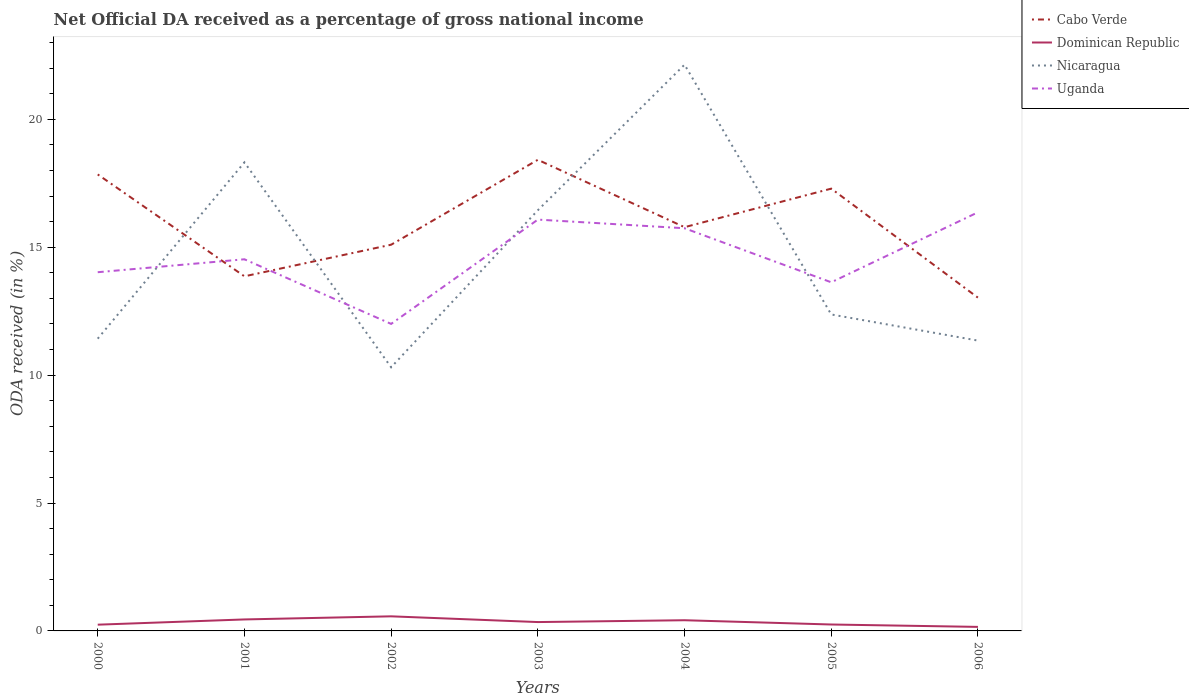How many different coloured lines are there?
Offer a very short reply. 4. Is the number of lines equal to the number of legend labels?
Offer a terse response. Yes. Across all years, what is the maximum net official DA received in Uganda?
Provide a succinct answer. 12. What is the total net official DA received in Nicaragua in the graph?
Provide a succinct answer. 1.02. What is the difference between the highest and the second highest net official DA received in Dominican Republic?
Make the answer very short. 0.41. What is the difference between the highest and the lowest net official DA received in Dominican Republic?
Keep it short and to the point. 3. How many lines are there?
Offer a very short reply. 4. Are the values on the major ticks of Y-axis written in scientific E-notation?
Provide a short and direct response. No. Does the graph contain any zero values?
Your response must be concise. No. Does the graph contain grids?
Your answer should be compact. No. What is the title of the graph?
Provide a short and direct response. Net Official DA received as a percentage of gross national income. What is the label or title of the Y-axis?
Your response must be concise. ODA received (in %). What is the ODA received (in %) of Cabo Verde in 2000?
Ensure brevity in your answer.  17.84. What is the ODA received (in %) in Dominican Republic in 2000?
Offer a very short reply. 0.24. What is the ODA received (in %) of Nicaragua in 2000?
Provide a succinct answer. 11.42. What is the ODA received (in %) of Uganda in 2000?
Keep it short and to the point. 14.02. What is the ODA received (in %) of Cabo Verde in 2001?
Provide a short and direct response. 13.86. What is the ODA received (in %) of Dominican Republic in 2001?
Keep it short and to the point. 0.45. What is the ODA received (in %) of Nicaragua in 2001?
Offer a terse response. 18.32. What is the ODA received (in %) in Uganda in 2001?
Your response must be concise. 14.53. What is the ODA received (in %) of Cabo Verde in 2002?
Your response must be concise. 15.1. What is the ODA received (in %) in Dominican Republic in 2002?
Provide a succinct answer. 0.57. What is the ODA received (in %) in Nicaragua in 2002?
Make the answer very short. 10.31. What is the ODA received (in %) of Uganda in 2002?
Your answer should be compact. 12. What is the ODA received (in %) in Cabo Verde in 2003?
Provide a short and direct response. 18.42. What is the ODA received (in %) in Dominican Republic in 2003?
Give a very brief answer. 0.35. What is the ODA received (in %) of Nicaragua in 2003?
Provide a succinct answer. 16.44. What is the ODA received (in %) of Uganda in 2003?
Your response must be concise. 16.08. What is the ODA received (in %) in Cabo Verde in 2004?
Your answer should be very brief. 15.78. What is the ODA received (in %) in Dominican Republic in 2004?
Your answer should be very brief. 0.42. What is the ODA received (in %) of Nicaragua in 2004?
Give a very brief answer. 22.13. What is the ODA received (in %) of Uganda in 2004?
Offer a terse response. 15.74. What is the ODA received (in %) of Cabo Verde in 2005?
Make the answer very short. 17.29. What is the ODA received (in %) of Dominican Republic in 2005?
Provide a short and direct response. 0.25. What is the ODA received (in %) of Nicaragua in 2005?
Your answer should be very brief. 12.37. What is the ODA received (in %) of Uganda in 2005?
Provide a short and direct response. 13.63. What is the ODA received (in %) in Cabo Verde in 2006?
Offer a very short reply. 13.03. What is the ODA received (in %) of Dominican Republic in 2006?
Ensure brevity in your answer.  0.16. What is the ODA received (in %) of Nicaragua in 2006?
Ensure brevity in your answer.  11.35. What is the ODA received (in %) of Uganda in 2006?
Keep it short and to the point. 16.36. Across all years, what is the maximum ODA received (in %) in Cabo Verde?
Offer a very short reply. 18.42. Across all years, what is the maximum ODA received (in %) of Dominican Republic?
Keep it short and to the point. 0.57. Across all years, what is the maximum ODA received (in %) in Nicaragua?
Your response must be concise. 22.13. Across all years, what is the maximum ODA received (in %) of Uganda?
Offer a terse response. 16.36. Across all years, what is the minimum ODA received (in %) of Cabo Verde?
Give a very brief answer. 13.03. Across all years, what is the minimum ODA received (in %) of Dominican Republic?
Your answer should be very brief. 0.16. Across all years, what is the minimum ODA received (in %) in Nicaragua?
Offer a terse response. 10.31. Across all years, what is the minimum ODA received (in %) in Uganda?
Offer a very short reply. 12. What is the total ODA received (in %) of Cabo Verde in the graph?
Offer a very short reply. 111.31. What is the total ODA received (in %) of Dominican Republic in the graph?
Provide a succinct answer. 2.44. What is the total ODA received (in %) in Nicaragua in the graph?
Provide a short and direct response. 102.34. What is the total ODA received (in %) in Uganda in the graph?
Provide a succinct answer. 102.36. What is the difference between the ODA received (in %) of Cabo Verde in 2000 and that in 2001?
Offer a very short reply. 3.98. What is the difference between the ODA received (in %) of Dominican Republic in 2000 and that in 2001?
Offer a very short reply. -0.2. What is the difference between the ODA received (in %) in Nicaragua in 2000 and that in 2001?
Keep it short and to the point. -6.89. What is the difference between the ODA received (in %) in Uganda in 2000 and that in 2001?
Your response must be concise. -0.51. What is the difference between the ODA received (in %) in Cabo Verde in 2000 and that in 2002?
Offer a terse response. 2.75. What is the difference between the ODA received (in %) in Dominican Republic in 2000 and that in 2002?
Your response must be concise. -0.33. What is the difference between the ODA received (in %) in Nicaragua in 2000 and that in 2002?
Keep it short and to the point. 1.12. What is the difference between the ODA received (in %) of Uganda in 2000 and that in 2002?
Give a very brief answer. 2.02. What is the difference between the ODA received (in %) in Cabo Verde in 2000 and that in 2003?
Provide a short and direct response. -0.57. What is the difference between the ODA received (in %) in Dominican Republic in 2000 and that in 2003?
Make the answer very short. -0.1. What is the difference between the ODA received (in %) in Nicaragua in 2000 and that in 2003?
Offer a very short reply. -5.02. What is the difference between the ODA received (in %) of Uganda in 2000 and that in 2003?
Offer a terse response. -2.06. What is the difference between the ODA received (in %) in Cabo Verde in 2000 and that in 2004?
Ensure brevity in your answer.  2.06. What is the difference between the ODA received (in %) of Dominican Republic in 2000 and that in 2004?
Keep it short and to the point. -0.17. What is the difference between the ODA received (in %) of Nicaragua in 2000 and that in 2004?
Make the answer very short. -10.71. What is the difference between the ODA received (in %) of Uganda in 2000 and that in 2004?
Your answer should be very brief. -1.72. What is the difference between the ODA received (in %) of Cabo Verde in 2000 and that in 2005?
Your answer should be very brief. 0.56. What is the difference between the ODA received (in %) in Dominican Republic in 2000 and that in 2005?
Give a very brief answer. -0.01. What is the difference between the ODA received (in %) of Nicaragua in 2000 and that in 2005?
Give a very brief answer. -0.95. What is the difference between the ODA received (in %) of Uganda in 2000 and that in 2005?
Provide a short and direct response. 0.39. What is the difference between the ODA received (in %) of Cabo Verde in 2000 and that in 2006?
Provide a succinct answer. 4.82. What is the difference between the ODA received (in %) in Dominican Republic in 2000 and that in 2006?
Ensure brevity in your answer.  0.09. What is the difference between the ODA received (in %) in Nicaragua in 2000 and that in 2006?
Ensure brevity in your answer.  0.07. What is the difference between the ODA received (in %) of Uganda in 2000 and that in 2006?
Give a very brief answer. -2.34. What is the difference between the ODA received (in %) in Cabo Verde in 2001 and that in 2002?
Give a very brief answer. -1.24. What is the difference between the ODA received (in %) of Dominican Republic in 2001 and that in 2002?
Provide a succinct answer. -0.12. What is the difference between the ODA received (in %) in Nicaragua in 2001 and that in 2002?
Ensure brevity in your answer.  8.01. What is the difference between the ODA received (in %) of Uganda in 2001 and that in 2002?
Provide a succinct answer. 2.53. What is the difference between the ODA received (in %) of Cabo Verde in 2001 and that in 2003?
Keep it short and to the point. -4.55. What is the difference between the ODA received (in %) in Dominican Republic in 2001 and that in 2003?
Keep it short and to the point. 0.1. What is the difference between the ODA received (in %) of Nicaragua in 2001 and that in 2003?
Make the answer very short. 1.87. What is the difference between the ODA received (in %) in Uganda in 2001 and that in 2003?
Give a very brief answer. -1.55. What is the difference between the ODA received (in %) of Cabo Verde in 2001 and that in 2004?
Give a very brief answer. -1.92. What is the difference between the ODA received (in %) of Dominican Republic in 2001 and that in 2004?
Keep it short and to the point. 0.03. What is the difference between the ODA received (in %) of Nicaragua in 2001 and that in 2004?
Keep it short and to the point. -3.82. What is the difference between the ODA received (in %) of Uganda in 2001 and that in 2004?
Your answer should be compact. -1.21. What is the difference between the ODA received (in %) in Cabo Verde in 2001 and that in 2005?
Make the answer very short. -3.43. What is the difference between the ODA received (in %) in Dominican Republic in 2001 and that in 2005?
Your answer should be compact. 0.2. What is the difference between the ODA received (in %) in Nicaragua in 2001 and that in 2005?
Offer a very short reply. 5.95. What is the difference between the ODA received (in %) in Uganda in 2001 and that in 2005?
Your response must be concise. 0.9. What is the difference between the ODA received (in %) of Cabo Verde in 2001 and that in 2006?
Keep it short and to the point. 0.83. What is the difference between the ODA received (in %) of Dominican Republic in 2001 and that in 2006?
Give a very brief answer. 0.29. What is the difference between the ODA received (in %) in Nicaragua in 2001 and that in 2006?
Offer a very short reply. 6.97. What is the difference between the ODA received (in %) in Uganda in 2001 and that in 2006?
Your answer should be compact. -1.84. What is the difference between the ODA received (in %) in Cabo Verde in 2002 and that in 2003?
Your answer should be compact. -3.32. What is the difference between the ODA received (in %) in Dominican Republic in 2002 and that in 2003?
Keep it short and to the point. 0.22. What is the difference between the ODA received (in %) of Nicaragua in 2002 and that in 2003?
Give a very brief answer. -6.14. What is the difference between the ODA received (in %) in Uganda in 2002 and that in 2003?
Make the answer very short. -4.08. What is the difference between the ODA received (in %) of Cabo Verde in 2002 and that in 2004?
Give a very brief answer. -0.69. What is the difference between the ODA received (in %) of Dominican Republic in 2002 and that in 2004?
Provide a succinct answer. 0.15. What is the difference between the ODA received (in %) in Nicaragua in 2002 and that in 2004?
Give a very brief answer. -11.83. What is the difference between the ODA received (in %) of Uganda in 2002 and that in 2004?
Your answer should be very brief. -3.74. What is the difference between the ODA received (in %) of Cabo Verde in 2002 and that in 2005?
Your response must be concise. -2.19. What is the difference between the ODA received (in %) in Dominican Republic in 2002 and that in 2005?
Your response must be concise. 0.32. What is the difference between the ODA received (in %) of Nicaragua in 2002 and that in 2005?
Offer a terse response. -2.06. What is the difference between the ODA received (in %) in Uganda in 2002 and that in 2005?
Keep it short and to the point. -1.63. What is the difference between the ODA received (in %) of Cabo Verde in 2002 and that in 2006?
Your answer should be compact. 2.07. What is the difference between the ODA received (in %) in Dominican Republic in 2002 and that in 2006?
Your response must be concise. 0.41. What is the difference between the ODA received (in %) of Nicaragua in 2002 and that in 2006?
Make the answer very short. -1.04. What is the difference between the ODA received (in %) in Uganda in 2002 and that in 2006?
Provide a short and direct response. -4.36. What is the difference between the ODA received (in %) of Cabo Verde in 2003 and that in 2004?
Your response must be concise. 2.63. What is the difference between the ODA received (in %) in Dominican Republic in 2003 and that in 2004?
Make the answer very short. -0.07. What is the difference between the ODA received (in %) in Nicaragua in 2003 and that in 2004?
Your answer should be compact. -5.69. What is the difference between the ODA received (in %) in Uganda in 2003 and that in 2004?
Offer a very short reply. 0.34. What is the difference between the ODA received (in %) of Cabo Verde in 2003 and that in 2005?
Your answer should be compact. 1.13. What is the difference between the ODA received (in %) in Dominican Republic in 2003 and that in 2005?
Your response must be concise. 0.1. What is the difference between the ODA received (in %) in Nicaragua in 2003 and that in 2005?
Your answer should be very brief. 4.07. What is the difference between the ODA received (in %) of Uganda in 2003 and that in 2005?
Your response must be concise. 2.45. What is the difference between the ODA received (in %) in Cabo Verde in 2003 and that in 2006?
Make the answer very short. 5.39. What is the difference between the ODA received (in %) in Dominican Republic in 2003 and that in 2006?
Provide a short and direct response. 0.19. What is the difference between the ODA received (in %) of Nicaragua in 2003 and that in 2006?
Your response must be concise. 5.09. What is the difference between the ODA received (in %) of Uganda in 2003 and that in 2006?
Your response must be concise. -0.29. What is the difference between the ODA received (in %) in Cabo Verde in 2004 and that in 2005?
Keep it short and to the point. -1.51. What is the difference between the ODA received (in %) of Dominican Republic in 2004 and that in 2005?
Offer a terse response. 0.17. What is the difference between the ODA received (in %) in Nicaragua in 2004 and that in 2005?
Ensure brevity in your answer.  9.76. What is the difference between the ODA received (in %) of Uganda in 2004 and that in 2005?
Provide a succinct answer. 2.11. What is the difference between the ODA received (in %) of Cabo Verde in 2004 and that in 2006?
Keep it short and to the point. 2.76. What is the difference between the ODA received (in %) in Dominican Republic in 2004 and that in 2006?
Provide a short and direct response. 0.26. What is the difference between the ODA received (in %) in Nicaragua in 2004 and that in 2006?
Make the answer very short. 10.78. What is the difference between the ODA received (in %) of Uganda in 2004 and that in 2006?
Provide a succinct answer. -0.62. What is the difference between the ODA received (in %) of Cabo Verde in 2005 and that in 2006?
Provide a short and direct response. 4.26. What is the difference between the ODA received (in %) in Dominican Republic in 2005 and that in 2006?
Give a very brief answer. 0.09. What is the difference between the ODA received (in %) of Nicaragua in 2005 and that in 2006?
Make the answer very short. 1.02. What is the difference between the ODA received (in %) in Uganda in 2005 and that in 2006?
Make the answer very short. -2.74. What is the difference between the ODA received (in %) in Cabo Verde in 2000 and the ODA received (in %) in Dominican Republic in 2001?
Offer a terse response. 17.39. What is the difference between the ODA received (in %) in Cabo Verde in 2000 and the ODA received (in %) in Nicaragua in 2001?
Your answer should be very brief. -0.47. What is the difference between the ODA received (in %) of Cabo Verde in 2000 and the ODA received (in %) of Uganda in 2001?
Your response must be concise. 3.32. What is the difference between the ODA received (in %) in Dominican Republic in 2000 and the ODA received (in %) in Nicaragua in 2001?
Your answer should be compact. -18.07. What is the difference between the ODA received (in %) in Dominican Republic in 2000 and the ODA received (in %) in Uganda in 2001?
Give a very brief answer. -14.28. What is the difference between the ODA received (in %) of Nicaragua in 2000 and the ODA received (in %) of Uganda in 2001?
Provide a succinct answer. -3.1. What is the difference between the ODA received (in %) in Cabo Verde in 2000 and the ODA received (in %) in Dominican Republic in 2002?
Provide a short and direct response. 17.27. What is the difference between the ODA received (in %) of Cabo Verde in 2000 and the ODA received (in %) of Nicaragua in 2002?
Provide a short and direct response. 7.54. What is the difference between the ODA received (in %) of Cabo Verde in 2000 and the ODA received (in %) of Uganda in 2002?
Ensure brevity in your answer.  5.84. What is the difference between the ODA received (in %) in Dominican Republic in 2000 and the ODA received (in %) in Nicaragua in 2002?
Your answer should be very brief. -10.06. What is the difference between the ODA received (in %) of Dominican Republic in 2000 and the ODA received (in %) of Uganda in 2002?
Offer a very short reply. -11.76. What is the difference between the ODA received (in %) of Nicaragua in 2000 and the ODA received (in %) of Uganda in 2002?
Your response must be concise. -0.58. What is the difference between the ODA received (in %) in Cabo Verde in 2000 and the ODA received (in %) in Dominican Republic in 2003?
Offer a very short reply. 17.5. What is the difference between the ODA received (in %) of Cabo Verde in 2000 and the ODA received (in %) of Nicaragua in 2003?
Your response must be concise. 1.4. What is the difference between the ODA received (in %) of Cabo Verde in 2000 and the ODA received (in %) of Uganda in 2003?
Offer a very short reply. 1.77. What is the difference between the ODA received (in %) of Dominican Republic in 2000 and the ODA received (in %) of Nicaragua in 2003?
Give a very brief answer. -16.2. What is the difference between the ODA received (in %) of Dominican Republic in 2000 and the ODA received (in %) of Uganda in 2003?
Offer a very short reply. -15.83. What is the difference between the ODA received (in %) in Nicaragua in 2000 and the ODA received (in %) in Uganda in 2003?
Provide a succinct answer. -4.65. What is the difference between the ODA received (in %) of Cabo Verde in 2000 and the ODA received (in %) of Dominican Republic in 2004?
Make the answer very short. 17.43. What is the difference between the ODA received (in %) of Cabo Verde in 2000 and the ODA received (in %) of Nicaragua in 2004?
Provide a short and direct response. -4.29. What is the difference between the ODA received (in %) of Cabo Verde in 2000 and the ODA received (in %) of Uganda in 2004?
Provide a succinct answer. 2.1. What is the difference between the ODA received (in %) of Dominican Republic in 2000 and the ODA received (in %) of Nicaragua in 2004?
Your response must be concise. -21.89. What is the difference between the ODA received (in %) of Dominican Republic in 2000 and the ODA received (in %) of Uganda in 2004?
Offer a terse response. -15.5. What is the difference between the ODA received (in %) of Nicaragua in 2000 and the ODA received (in %) of Uganda in 2004?
Keep it short and to the point. -4.32. What is the difference between the ODA received (in %) in Cabo Verde in 2000 and the ODA received (in %) in Dominican Republic in 2005?
Provide a short and direct response. 17.59. What is the difference between the ODA received (in %) in Cabo Verde in 2000 and the ODA received (in %) in Nicaragua in 2005?
Your answer should be compact. 5.47. What is the difference between the ODA received (in %) in Cabo Verde in 2000 and the ODA received (in %) in Uganda in 2005?
Offer a very short reply. 4.22. What is the difference between the ODA received (in %) in Dominican Republic in 2000 and the ODA received (in %) in Nicaragua in 2005?
Your response must be concise. -12.13. What is the difference between the ODA received (in %) in Dominican Republic in 2000 and the ODA received (in %) in Uganda in 2005?
Give a very brief answer. -13.38. What is the difference between the ODA received (in %) of Nicaragua in 2000 and the ODA received (in %) of Uganda in 2005?
Ensure brevity in your answer.  -2.2. What is the difference between the ODA received (in %) of Cabo Verde in 2000 and the ODA received (in %) of Dominican Republic in 2006?
Give a very brief answer. 17.69. What is the difference between the ODA received (in %) in Cabo Verde in 2000 and the ODA received (in %) in Nicaragua in 2006?
Your answer should be compact. 6.5. What is the difference between the ODA received (in %) in Cabo Verde in 2000 and the ODA received (in %) in Uganda in 2006?
Offer a terse response. 1.48. What is the difference between the ODA received (in %) of Dominican Republic in 2000 and the ODA received (in %) of Nicaragua in 2006?
Your answer should be very brief. -11.1. What is the difference between the ODA received (in %) in Dominican Republic in 2000 and the ODA received (in %) in Uganda in 2006?
Provide a short and direct response. -16.12. What is the difference between the ODA received (in %) in Nicaragua in 2000 and the ODA received (in %) in Uganda in 2006?
Offer a terse response. -4.94. What is the difference between the ODA received (in %) of Cabo Verde in 2001 and the ODA received (in %) of Dominican Republic in 2002?
Your answer should be very brief. 13.29. What is the difference between the ODA received (in %) in Cabo Verde in 2001 and the ODA received (in %) in Nicaragua in 2002?
Offer a terse response. 3.56. What is the difference between the ODA received (in %) of Cabo Verde in 2001 and the ODA received (in %) of Uganda in 2002?
Ensure brevity in your answer.  1.86. What is the difference between the ODA received (in %) of Dominican Republic in 2001 and the ODA received (in %) of Nicaragua in 2002?
Make the answer very short. -9.86. What is the difference between the ODA received (in %) of Dominican Republic in 2001 and the ODA received (in %) of Uganda in 2002?
Give a very brief answer. -11.55. What is the difference between the ODA received (in %) of Nicaragua in 2001 and the ODA received (in %) of Uganda in 2002?
Your response must be concise. 6.32. What is the difference between the ODA received (in %) in Cabo Verde in 2001 and the ODA received (in %) in Dominican Republic in 2003?
Your answer should be compact. 13.51. What is the difference between the ODA received (in %) in Cabo Verde in 2001 and the ODA received (in %) in Nicaragua in 2003?
Keep it short and to the point. -2.58. What is the difference between the ODA received (in %) in Cabo Verde in 2001 and the ODA received (in %) in Uganda in 2003?
Give a very brief answer. -2.22. What is the difference between the ODA received (in %) in Dominican Republic in 2001 and the ODA received (in %) in Nicaragua in 2003?
Ensure brevity in your answer.  -15.99. What is the difference between the ODA received (in %) of Dominican Republic in 2001 and the ODA received (in %) of Uganda in 2003?
Give a very brief answer. -15.63. What is the difference between the ODA received (in %) in Nicaragua in 2001 and the ODA received (in %) in Uganda in 2003?
Offer a very short reply. 2.24. What is the difference between the ODA received (in %) in Cabo Verde in 2001 and the ODA received (in %) in Dominican Republic in 2004?
Provide a succinct answer. 13.44. What is the difference between the ODA received (in %) in Cabo Verde in 2001 and the ODA received (in %) in Nicaragua in 2004?
Your answer should be compact. -8.27. What is the difference between the ODA received (in %) of Cabo Verde in 2001 and the ODA received (in %) of Uganda in 2004?
Offer a very short reply. -1.88. What is the difference between the ODA received (in %) of Dominican Republic in 2001 and the ODA received (in %) of Nicaragua in 2004?
Ensure brevity in your answer.  -21.68. What is the difference between the ODA received (in %) of Dominican Republic in 2001 and the ODA received (in %) of Uganda in 2004?
Your answer should be very brief. -15.29. What is the difference between the ODA received (in %) in Nicaragua in 2001 and the ODA received (in %) in Uganda in 2004?
Your response must be concise. 2.58. What is the difference between the ODA received (in %) in Cabo Verde in 2001 and the ODA received (in %) in Dominican Republic in 2005?
Provide a succinct answer. 13.61. What is the difference between the ODA received (in %) in Cabo Verde in 2001 and the ODA received (in %) in Nicaragua in 2005?
Make the answer very short. 1.49. What is the difference between the ODA received (in %) in Cabo Verde in 2001 and the ODA received (in %) in Uganda in 2005?
Give a very brief answer. 0.23. What is the difference between the ODA received (in %) in Dominican Republic in 2001 and the ODA received (in %) in Nicaragua in 2005?
Your answer should be very brief. -11.92. What is the difference between the ODA received (in %) in Dominican Republic in 2001 and the ODA received (in %) in Uganda in 2005?
Offer a very short reply. -13.18. What is the difference between the ODA received (in %) in Nicaragua in 2001 and the ODA received (in %) in Uganda in 2005?
Offer a terse response. 4.69. What is the difference between the ODA received (in %) of Cabo Verde in 2001 and the ODA received (in %) of Dominican Republic in 2006?
Your response must be concise. 13.7. What is the difference between the ODA received (in %) of Cabo Verde in 2001 and the ODA received (in %) of Nicaragua in 2006?
Provide a short and direct response. 2.51. What is the difference between the ODA received (in %) in Cabo Verde in 2001 and the ODA received (in %) in Uganda in 2006?
Offer a terse response. -2.5. What is the difference between the ODA received (in %) of Dominican Republic in 2001 and the ODA received (in %) of Nicaragua in 2006?
Provide a short and direct response. -10.9. What is the difference between the ODA received (in %) of Dominican Republic in 2001 and the ODA received (in %) of Uganda in 2006?
Ensure brevity in your answer.  -15.91. What is the difference between the ODA received (in %) of Nicaragua in 2001 and the ODA received (in %) of Uganda in 2006?
Your answer should be compact. 1.95. What is the difference between the ODA received (in %) in Cabo Verde in 2002 and the ODA received (in %) in Dominican Republic in 2003?
Your response must be concise. 14.75. What is the difference between the ODA received (in %) of Cabo Verde in 2002 and the ODA received (in %) of Nicaragua in 2003?
Offer a very short reply. -1.35. What is the difference between the ODA received (in %) in Cabo Verde in 2002 and the ODA received (in %) in Uganda in 2003?
Keep it short and to the point. -0.98. What is the difference between the ODA received (in %) of Dominican Republic in 2002 and the ODA received (in %) of Nicaragua in 2003?
Give a very brief answer. -15.87. What is the difference between the ODA received (in %) in Dominican Republic in 2002 and the ODA received (in %) in Uganda in 2003?
Provide a short and direct response. -15.51. What is the difference between the ODA received (in %) in Nicaragua in 2002 and the ODA received (in %) in Uganda in 2003?
Ensure brevity in your answer.  -5.77. What is the difference between the ODA received (in %) in Cabo Verde in 2002 and the ODA received (in %) in Dominican Republic in 2004?
Make the answer very short. 14.68. What is the difference between the ODA received (in %) of Cabo Verde in 2002 and the ODA received (in %) of Nicaragua in 2004?
Provide a short and direct response. -7.04. What is the difference between the ODA received (in %) of Cabo Verde in 2002 and the ODA received (in %) of Uganda in 2004?
Offer a terse response. -0.64. What is the difference between the ODA received (in %) of Dominican Republic in 2002 and the ODA received (in %) of Nicaragua in 2004?
Make the answer very short. -21.56. What is the difference between the ODA received (in %) of Dominican Republic in 2002 and the ODA received (in %) of Uganda in 2004?
Provide a short and direct response. -15.17. What is the difference between the ODA received (in %) in Nicaragua in 2002 and the ODA received (in %) in Uganda in 2004?
Provide a short and direct response. -5.43. What is the difference between the ODA received (in %) of Cabo Verde in 2002 and the ODA received (in %) of Dominican Republic in 2005?
Give a very brief answer. 14.85. What is the difference between the ODA received (in %) of Cabo Verde in 2002 and the ODA received (in %) of Nicaragua in 2005?
Make the answer very short. 2.73. What is the difference between the ODA received (in %) of Cabo Verde in 2002 and the ODA received (in %) of Uganda in 2005?
Offer a very short reply. 1.47. What is the difference between the ODA received (in %) in Dominican Republic in 2002 and the ODA received (in %) in Nicaragua in 2005?
Give a very brief answer. -11.8. What is the difference between the ODA received (in %) in Dominican Republic in 2002 and the ODA received (in %) in Uganda in 2005?
Ensure brevity in your answer.  -13.06. What is the difference between the ODA received (in %) of Nicaragua in 2002 and the ODA received (in %) of Uganda in 2005?
Your answer should be compact. -3.32. What is the difference between the ODA received (in %) in Cabo Verde in 2002 and the ODA received (in %) in Dominican Republic in 2006?
Provide a short and direct response. 14.94. What is the difference between the ODA received (in %) of Cabo Verde in 2002 and the ODA received (in %) of Nicaragua in 2006?
Offer a very short reply. 3.75. What is the difference between the ODA received (in %) in Cabo Verde in 2002 and the ODA received (in %) in Uganda in 2006?
Provide a succinct answer. -1.27. What is the difference between the ODA received (in %) in Dominican Republic in 2002 and the ODA received (in %) in Nicaragua in 2006?
Make the answer very short. -10.78. What is the difference between the ODA received (in %) in Dominican Republic in 2002 and the ODA received (in %) in Uganda in 2006?
Provide a short and direct response. -15.79. What is the difference between the ODA received (in %) in Nicaragua in 2002 and the ODA received (in %) in Uganda in 2006?
Your response must be concise. -6.06. What is the difference between the ODA received (in %) of Cabo Verde in 2003 and the ODA received (in %) of Dominican Republic in 2004?
Offer a very short reply. 18. What is the difference between the ODA received (in %) of Cabo Verde in 2003 and the ODA received (in %) of Nicaragua in 2004?
Provide a succinct answer. -3.72. What is the difference between the ODA received (in %) of Cabo Verde in 2003 and the ODA received (in %) of Uganda in 2004?
Keep it short and to the point. 2.68. What is the difference between the ODA received (in %) in Dominican Republic in 2003 and the ODA received (in %) in Nicaragua in 2004?
Your answer should be very brief. -21.79. What is the difference between the ODA received (in %) of Dominican Republic in 2003 and the ODA received (in %) of Uganda in 2004?
Your response must be concise. -15.39. What is the difference between the ODA received (in %) of Nicaragua in 2003 and the ODA received (in %) of Uganda in 2004?
Your answer should be compact. 0.7. What is the difference between the ODA received (in %) in Cabo Verde in 2003 and the ODA received (in %) in Dominican Republic in 2005?
Provide a short and direct response. 18.16. What is the difference between the ODA received (in %) of Cabo Verde in 2003 and the ODA received (in %) of Nicaragua in 2005?
Provide a succinct answer. 6.05. What is the difference between the ODA received (in %) of Cabo Verde in 2003 and the ODA received (in %) of Uganda in 2005?
Ensure brevity in your answer.  4.79. What is the difference between the ODA received (in %) of Dominican Republic in 2003 and the ODA received (in %) of Nicaragua in 2005?
Your response must be concise. -12.02. What is the difference between the ODA received (in %) in Dominican Republic in 2003 and the ODA received (in %) in Uganda in 2005?
Offer a terse response. -13.28. What is the difference between the ODA received (in %) of Nicaragua in 2003 and the ODA received (in %) of Uganda in 2005?
Provide a succinct answer. 2.82. What is the difference between the ODA received (in %) of Cabo Verde in 2003 and the ODA received (in %) of Dominican Republic in 2006?
Give a very brief answer. 18.26. What is the difference between the ODA received (in %) of Cabo Verde in 2003 and the ODA received (in %) of Nicaragua in 2006?
Your answer should be very brief. 7.07. What is the difference between the ODA received (in %) in Cabo Verde in 2003 and the ODA received (in %) in Uganda in 2006?
Make the answer very short. 2.05. What is the difference between the ODA received (in %) in Dominican Republic in 2003 and the ODA received (in %) in Nicaragua in 2006?
Provide a succinct answer. -11. What is the difference between the ODA received (in %) in Dominican Republic in 2003 and the ODA received (in %) in Uganda in 2006?
Make the answer very short. -16.02. What is the difference between the ODA received (in %) in Nicaragua in 2003 and the ODA received (in %) in Uganda in 2006?
Ensure brevity in your answer.  0.08. What is the difference between the ODA received (in %) in Cabo Verde in 2004 and the ODA received (in %) in Dominican Republic in 2005?
Your response must be concise. 15.53. What is the difference between the ODA received (in %) of Cabo Verde in 2004 and the ODA received (in %) of Nicaragua in 2005?
Make the answer very short. 3.41. What is the difference between the ODA received (in %) of Cabo Verde in 2004 and the ODA received (in %) of Uganda in 2005?
Your response must be concise. 2.15. What is the difference between the ODA received (in %) of Dominican Republic in 2004 and the ODA received (in %) of Nicaragua in 2005?
Keep it short and to the point. -11.95. What is the difference between the ODA received (in %) of Dominican Republic in 2004 and the ODA received (in %) of Uganda in 2005?
Provide a succinct answer. -13.21. What is the difference between the ODA received (in %) in Nicaragua in 2004 and the ODA received (in %) in Uganda in 2005?
Provide a succinct answer. 8.51. What is the difference between the ODA received (in %) in Cabo Verde in 2004 and the ODA received (in %) in Dominican Republic in 2006?
Keep it short and to the point. 15.62. What is the difference between the ODA received (in %) in Cabo Verde in 2004 and the ODA received (in %) in Nicaragua in 2006?
Provide a succinct answer. 4.43. What is the difference between the ODA received (in %) of Cabo Verde in 2004 and the ODA received (in %) of Uganda in 2006?
Provide a succinct answer. -0.58. What is the difference between the ODA received (in %) in Dominican Republic in 2004 and the ODA received (in %) in Nicaragua in 2006?
Your answer should be compact. -10.93. What is the difference between the ODA received (in %) in Dominican Republic in 2004 and the ODA received (in %) in Uganda in 2006?
Your response must be concise. -15.95. What is the difference between the ODA received (in %) in Nicaragua in 2004 and the ODA received (in %) in Uganda in 2006?
Give a very brief answer. 5.77. What is the difference between the ODA received (in %) of Cabo Verde in 2005 and the ODA received (in %) of Dominican Republic in 2006?
Your response must be concise. 17.13. What is the difference between the ODA received (in %) of Cabo Verde in 2005 and the ODA received (in %) of Nicaragua in 2006?
Keep it short and to the point. 5.94. What is the difference between the ODA received (in %) of Cabo Verde in 2005 and the ODA received (in %) of Uganda in 2006?
Ensure brevity in your answer.  0.92. What is the difference between the ODA received (in %) in Dominican Republic in 2005 and the ODA received (in %) in Nicaragua in 2006?
Keep it short and to the point. -11.1. What is the difference between the ODA received (in %) of Dominican Republic in 2005 and the ODA received (in %) of Uganda in 2006?
Your answer should be compact. -16.11. What is the difference between the ODA received (in %) in Nicaragua in 2005 and the ODA received (in %) in Uganda in 2006?
Your answer should be compact. -3.99. What is the average ODA received (in %) in Cabo Verde per year?
Keep it short and to the point. 15.9. What is the average ODA received (in %) of Dominican Republic per year?
Your answer should be compact. 0.35. What is the average ODA received (in %) in Nicaragua per year?
Make the answer very short. 14.62. What is the average ODA received (in %) in Uganda per year?
Provide a succinct answer. 14.62. In the year 2000, what is the difference between the ODA received (in %) in Cabo Verde and ODA received (in %) in Dominican Republic?
Give a very brief answer. 17.6. In the year 2000, what is the difference between the ODA received (in %) of Cabo Verde and ODA received (in %) of Nicaragua?
Offer a terse response. 6.42. In the year 2000, what is the difference between the ODA received (in %) of Cabo Verde and ODA received (in %) of Uganda?
Ensure brevity in your answer.  3.82. In the year 2000, what is the difference between the ODA received (in %) in Dominican Republic and ODA received (in %) in Nicaragua?
Your response must be concise. -11.18. In the year 2000, what is the difference between the ODA received (in %) in Dominican Republic and ODA received (in %) in Uganda?
Your answer should be very brief. -13.78. In the year 2000, what is the difference between the ODA received (in %) in Nicaragua and ODA received (in %) in Uganda?
Make the answer very short. -2.6. In the year 2001, what is the difference between the ODA received (in %) of Cabo Verde and ODA received (in %) of Dominican Republic?
Give a very brief answer. 13.41. In the year 2001, what is the difference between the ODA received (in %) of Cabo Verde and ODA received (in %) of Nicaragua?
Ensure brevity in your answer.  -4.45. In the year 2001, what is the difference between the ODA received (in %) of Cabo Verde and ODA received (in %) of Uganda?
Your response must be concise. -0.67. In the year 2001, what is the difference between the ODA received (in %) of Dominican Republic and ODA received (in %) of Nicaragua?
Make the answer very short. -17.87. In the year 2001, what is the difference between the ODA received (in %) of Dominican Republic and ODA received (in %) of Uganda?
Give a very brief answer. -14.08. In the year 2001, what is the difference between the ODA received (in %) in Nicaragua and ODA received (in %) in Uganda?
Make the answer very short. 3.79. In the year 2002, what is the difference between the ODA received (in %) of Cabo Verde and ODA received (in %) of Dominican Republic?
Offer a very short reply. 14.53. In the year 2002, what is the difference between the ODA received (in %) in Cabo Verde and ODA received (in %) in Nicaragua?
Provide a short and direct response. 4.79. In the year 2002, what is the difference between the ODA received (in %) in Cabo Verde and ODA received (in %) in Uganda?
Your response must be concise. 3.1. In the year 2002, what is the difference between the ODA received (in %) of Dominican Republic and ODA received (in %) of Nicaragua?
Your response must be concise. -9.74. In the year 2002, what is the difference between the ODA received (in %) of Dominican Republic and ODA received (in %) of Uganda?
Provide a short and direct response. -11.43. In the year 2002, what is the difference between the ODA received (in %) in Nicaragua and ODA received (in %) in Uganda?
Provide a short and direct response. -1.7. In the year 2003, what is the difference between the ODA received (in %) in Cabo Verde and ODA received (in %) in Dominican Republic?
Make the answer very short. 18.07. In the year 2003, what is the difference between the ODA received (in %) in Cabo Verde and ODA received (in %) in Nicaragua?
Your answer should be very brief. 1.97. In the year 2003, what is the difference between the ODA received (in %) in Cabo Verde and ODA received (in %) in Uganda?
Keep it short and to the point. 2.34. In the year 2003, what is the difference between the ODA received (in %) in Dominican Republic and ODA received (in %) in Nicaragua?
Make the answer very short. -16.1. In the year 2003, what is the difference between the ODA received (in %) in Dominican Republic and ODA received (in %) in Uganda?
Your response must be concise. -15.73. In the year 2003, what is the difference between the ODA received (in %) of Nicaragua and ODA received (in %) of Uganda?
Your answer should be very brief. 0.37. In the year 2004, what is the difference between the ODA received (in %) in Cabo Verde and ODA received (in %) in Dominican Republic?
Your response must be concise. 15.36. In the year 2004, what is the difference between the ODA received (in %) of Cabo Verde and ODA received (in %) of Nicaragua?
Keep it short and to the point. -6.35. In the year 2004, what is the difference between the ODA received (in %) of Cabo Verde and ODA received (in %) of Uganda?
Offer a terse response. 0.04. In the year 2004, what is the difference between the ODA received (in %) in Dominican Republic and ODA received (in %) in Nicaragua?
Provide a short and direct response. -21.72. In the year 2004, what is the difference between the ODA received (in %) in Dominican Republic and ODA received (in %) in Uganda?
Keep it short and to the point. -15.32. In the year 2004, what is the difference between the ODA received (in %) of Nicaragua and ODA received (in %) of Uganda?
Your response must be concise. 6.39. In the year 2005, what is the difference between the ODA received (in %) in Cabo Verde and ODA received (in %) in Dominican Republic?
Keep it short and to the point. 17.04. In the year 2005, what is the difference between the ODA received (in %) in Cabo Verde and ODA received (in %) in Nicaragua?
Offer a very short reply. 4.92. In the year 2005, what is the difference between the ODA received (in %) in Cabo Verde and ODA received (in %) in Uganda?
Provide a succinct answer. 3.66. In the year 2005, what is the difference between the ODA received (in %) in Dominican Republic and ODA received (in %) in Nicaragua?
Your answer should be very brief. -12.12. In the year 2005, what is the difference between the ODA received (in %) in Dominican Republic and ODA received (in %) in Uganda?
Offer a very short reply. -13.38. In the year 2005, what is the difference between the ODA received (in %) in Nicaragua and ODA received (in %) in Uganda?
Your response must be concise. -1.26. In the year 2006, what is the difference between the ODA received (in %) of Cabo Verde and ODA received (in %) of Dominican Republic?
Your response must be concise. 12.87. In the year 2006, what is the difference between the ODA received (in %) of Cabo Verde and ODA received (in %) of Nicaragua?
Your answer should be compact. 1.68. In the year 2006, what is the difference between the ODA received (in %) in Cabo Verde and ODA received (in %) in Uganda?
Your response must be concise. -3.34. In the year 2006, what is the difference between the ODA received (in %) of Dominican Republic and ODA received (in %) of Nicaragua?
Your answer should be compact. -11.19. In the year 2006, what is the difference between the ODA received (in %) in Dominican Republic and ODA received (in %) in Uganda?
Provide a succinct answer. -16.21. In the year 2006, what is the difference between the ODA received (in %) of Nicaragua and ODA received (in %) of Uganda?
Your answer should be compact. -5.02. What is the ratio of the ODA received (in %) in Cabo Verde in 2000 to that in 2001?
Keep it short and to the point. 1.29. What is the ratio of the ODA received (in %) of Dominican Republic in 2000 to that in 2001?
Your answer should be compact. 0.54. What is the ratio of the ODA received (in %) in Nicaragua in 2000 to that in 2001?
Your answer should be very brief. 0.62. What is the ratio of the ODA received (in %) of Uganda in 2000 to that in 2001?
Offer a terse response. 0.97. What is the ratio of the ODA received (in %) in Cabo Verde in 2000 to that in 2002?
Ensure brevity in your answer.  1.18. What is the ratio of the ODA received (in %) of Dominican Republic in 2000 to that in 2002?
Offer a terse response. 0.43. What is the ratio of the ODA received (in %) in Nicaragua in 2000 to that in 2002?
Your answer should be compact. 1.11. What is the ratio of the ODA received (in %) of Uganda in 2000 to that in 2002?
Provide a succinct answer. 1.17. What is the ratio of the ODA received (in %) in Cabo Verde in 2000 to that in 2003?
Offer a very short reply. 0.97. What is the ratio of the ODA received (in %) of Dominican Republic in 2000 to that in 2003?
Provide a succinct answer. 0.7. What is the ratio of the ODA received (in %) in Nicaragua in 2000 to that in 2003?
Offer a very short reply. 0.69. What is the ratio of the ODA received (in %) of Uganda in 2000 to that in 2003?
Your answer should be very brief. 0.87. What is the ratio of the ODA received (in %) in Cabo Verde in 2000 to that in 2004?
Your response must be concise. 1.13. What is the ratio of the ODA received (in %) in Dominican Republic in 2000 to that in 2004?
Make the answer very short. 0.58. What is the ratio of the ODA received (in %) of Nicaragua in 2000 to that in 2004?
Your answer should be very brief. 0.52. What is the ratio of the ODA received (in %) of Uganda in 2000 to that in 2004?
Provide a succinct answer. 0.89. What is the ratio of the ODA received (in %) in Cabo Verde in 2000 to that in 2005?
Your answer should be very brief. 1.03. What is the ratio of the ODA received (in %) in Dominican Republic in 2000 to that in 2005?
Provide a succinct answer. 0.97. What is the ratio of the ODA received (in %) in Nicaragua in 2000 to that in 2005?
Your answer should be very brief. 0.92. What is the ratio of the ODA received (in %) in Uganda in 2000 to that in 2005?
Offer a very short reply. 1.03. What is the ratio of the ODA received (in %) in Cabo Verde in 2000 to that in 2006?
Provide a short and direct response. 1.37. What is the ratio of the ODA received (in %) in Dominican Republic in 2000 to that in 2006?
Your response must be concise. 1.55. What is the ratio of the ODA received (in %) of Nicaragua in 2000 to that in 2006?
Keep it short and to the point. 1.01. What is the ratio of the ODA received (in %) of Uganda in 2000 to that in 2006?
Keep it short and to the point. 0.86. What is the ratio of the ODA received (in %) of Cabo Verde in 2001 to that in 2002?
Offer a very short reply. 0.92. What is the ratio of the ODA received (in %) in Dominican Republic in 2001 to that in 2002?
Make the answer very short. 0.79. What is the ratio of the ODA received (in %) in Nicaragua in 2001 to that in 2002?
Provide a short and direct response. 1.78. What is the ratio of the ODA received (in %) of Uganda in 2001 to that in 2002?
Offer a very short reply. 1.21. What is the ratio of the ODA received (in %) of Cabo Verde in 2001 to that in 2003?
Ensure brevity in your answer.  0.75. What is the ratio of the ODA received (in %) in Dominican Republic in 2001 to that in 2003?
Give a very brief answer. 1.3. What is the ratio of the ODA received (in %) in Nicaragua in 2001 to that in 2003?
Offer a very short reply. 1.11. What is the ratio of the ODA received (in %) of Uganda in 2001 to that in 2003?
Offer a very short reply. 0.9. What is the ratio of the ODA received (in %) in Cabo Verde in 2001 to that in 2004?
Make the answer very short. 0.88. What is the ratio of the ODA received (in %) in Dominican Republic in 2001 to that in 2004?
Your response must be concise. 1.07. What is the ratio of the ODA received (in %) in Nicaragua in 2001 to that in 2004?
Ensure brevity in your answer.  0.83. What is the ratio of the ODA received (in %) of Uganda in 2001 to that in 2004?
Keep it short and to the point. 0.92. What is the ratio of the ODA received (in %) of Cabo Verde in 2001 to that in 2005?
Offer a very short reply. 0.8. What is the ratio of the ODA received (in %) of Dominican Republic in 2001 to that in 2005?
Give a very brief answer. 1.79. What is the ratio of the ODA received (in %) in Nicaragua in 2001 to that in 2005?
Offer a very short reply. 1.48. What is the ratio of the ODA received (in %) in Uganda in 2001 to that in 2005?
Your response must be concise. 1.07. What is the ratio of the ODA received (in %) of Cabo Verde in 2001 to that in 2006?
Your answer should be compact. 1.06. What is the ratio of the ODA received (in %) in Dominican Republic in 2001 to that in 2006?
Make the answer very short. 2.85. What is the ratio of the ODA received (in %) of Nicaragua in 2001 to that in 2006?
Offer a very short reply. 1.61. What is the ratio of the ODA received (in %) in Uganda in 2001 to that in 2006?
Offer a very short reply. 0.89. What is the ratio of the ODA received (in %) in Cabo Verde in 2002 to that in 2003?
Offer a very short reply. 0.82. What is the ratio of the ODA received (in %) in Dominican Republic in 2002 to that in 2003?
Your answer should be compact. 1.65. What is the ratio of the ODA received (in %) in Nicaragua in 2002 to that in 2003?
Offer a very short reply. 0.63. What is the ratio of the ODA received (in %) in Uganda in 2002 to that in 2003?
Provide a short and direct response. 0.75. What is the ratio of the ODA received (in %) of Cabo Verde in 2002 to that in 2004?
Make the answer very short. 0.96. What is the ratio of the ODA received (in %) of Dominican Republic in 2002 to that in 2004?
Give a very brief answer. 1.36. What is the ratio of the ODA received (in %) in Nicaragua in 2002 to that in 2004?
Provide a succinct answer. 0.47. What is the ratio of the ODA received (in %) in Uganda in 2002 to that in 2004?
Provide a short and direct response. 0.76. What is the ratio of the ODA received (in %) in Cabo Verde in 2002 to that in 2005?
Your answer should be very brief. 0.87. What is the ratio of the ODA received (in %) in Dominican Republic in 2002 to that in 2005?
Provide a succinct answer. 2.27. What is the ratio of the ODA received (in %) of Nicaragua in 2002 to that in 2005?
Offer a terse response. 0.83. What is the ratio of the ODA received (in %) of Uganda in 2002 to that in 2005?
Your answer should be compact. 0.88. What is the ratio of the ODA received (in %) in Cabo Verde in 2002 to that in 2006?
Your answer should be very brief. 1.16. What is the ratio of the ODA received (in %) in Dominican Republic in 2002 to that in 2006?
Keep it short and to the point. 3.61. What is the ratio of the ODA received (in %) of Nicaragua in 2002 to that in 2006?
Your answer should be very brief. 0.91. What is the ratio of the ODA received (in %) of Uganda in 2002 to that in 2006?
Give a very brief answer. 0.73. What is the ratio of the ODA received (in %) in Cabo Verde in 2003 to that in 2004?
Offer a very short reply. 1.17. What is the ratio of the ODA received (in %) of Dominican Republic in 2003 to that in 2004?
Your answer should be compact. 0.83. What is the ratio of the ODA received (in %) in Nicaragua in 2003 to that in 2004?
Your answer should be compact. 0.74. What is the ratio of the ODA received (in %) in Uganda in 2003 to that in 2004?
Make the answer very short. 1.02. What is the ratio of the ODA received (in %) of Cabo Verde in 2003 to that in 2005?
Provide a succinct answer. 1.07. What is the ratio of the ODA received (in %) in Dominican Republic in 2003 to that in 2005?
Provide a short and direct response. 1.38. What is the ratio of the ODA received (in %) in Nicaragua in 2003 to that in 2005?
Your response must be concise. 1.33. What is the ratio of the ODA received (in %) of Uganda in 2003 to that in 2005?
Your answer should be compact. 1.18. What is the ratio of the ODA received (in %) in Cabo Verde in 2003 to that in 2006?
Your response must be concise. 1.41. What is the ratio of the ODA received (in %) in Dominican Republic in 2003 to that in 2006?
Give a very brief answer. 2.2. What is the ratio of the ODA received (in %) in Nicaragua in 2003 to that in 2006?
Make the answer very short. 1.45. What is the ratio of the ODA received (in %) in Uganda in 2003 to that in 2006?
Provide a short and direct response. 0.98. What is the ratio of the ODA received (in %) in Cabo Verde in 2004 to that in 2005?
Keep it short and to the point. 0.91. What is the ratio of the ODA received (in %) in Dominican Republic in 2004 to that in 2005?
Offer a terse response. 1.66. What is the ratio of the ODA received (in %) of Nicaragua in 2004 to that in 2005?
Ensure brevity in your answer.  1.79. What is the ratio of the ODA received (in %) of Uganda in 2004 to that in 2005?
Your response must be concise. 1.16. What is the ratio of the ODA received (in %) in Cabo Verde in 2004 to that in 2006?
Provide a succinct answer. 1.21. What is the ratio of the ODA received (in %) of Dominican Republic in 2004 to that in 2006?
Keep it short and to the point. 2.65. What is the ratio of the ODA received (in %) of Nicaragua in 2004 to that in 2006?
Offer a terse response. 1.95. What is the ratio of the ODA received (in %) in Uganda in 2004 to that in 2006?
Offer a very short reply. 0.96. What is the ratio of the ODA received (in %) of Cabo Verde in 2005 to that in 2006?
Make the answer very short. 1.33. What is the ratio of the ODA received (in %) of Dominican Republic in 2005 to that in 2006?
Provide a short and direct response. 1.59. What is the ratio of the ODA received (in %) of Nicaragua in 2005 to that in 2006?
Ensure brevity in your answer.  1.09. What is the ratio of the ODA received (in %) of Uganda in 2005 to that in 2006?
Provide a succinct answer. 0.83. What is the difference between the highest and the second highest ODA received (in %) of Cabo Verde?
Your answer should be compact. 0.57. What is the difference between the highest and the second highest ODA received (in %) of Dominican Republic?
Your response must be concise. 0.12. What is the difference between the highest and the second highest ODA received (in %) in Nicaragua?
Provide a short and direct response. 3.82. What is the difference between the highest and the second highest ODA received (in %) in Uganda?
Provide a short and direct response. 0.29. What is the difference between the highest and the lowest ODA received (in %) of Cabo Verde?
Your response must be concise. 5.39. What is the difference between the highest and the lowest ODA received (in %) of Dominican Republic?
Keep it short and to the point. 0.41. What is the difference between the highest and the lowest ODA received (in %) in Nicaragua?
Keep it short and to the point. 11.83. What is the difference between the highest and the lowest ODA received (in %) in Uganda?
Make the answer very short. 4.36. 